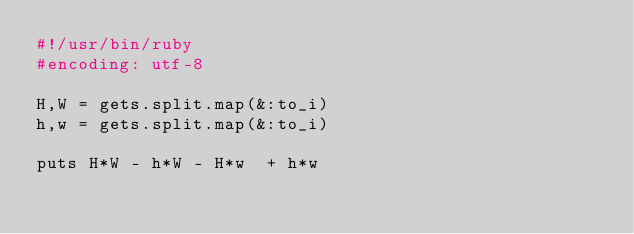Convert code to text. <code><loc_0><loc_0><loc_500><loc_500><_Ruby_>#!/usr/bin/ruby
#encoding: utf-8

H,W = gets.split.map(&:to_i) 
h,w = gets.split.map(&:to_i) 

puts H*W - h*W - H*w  + h*w
</code> 